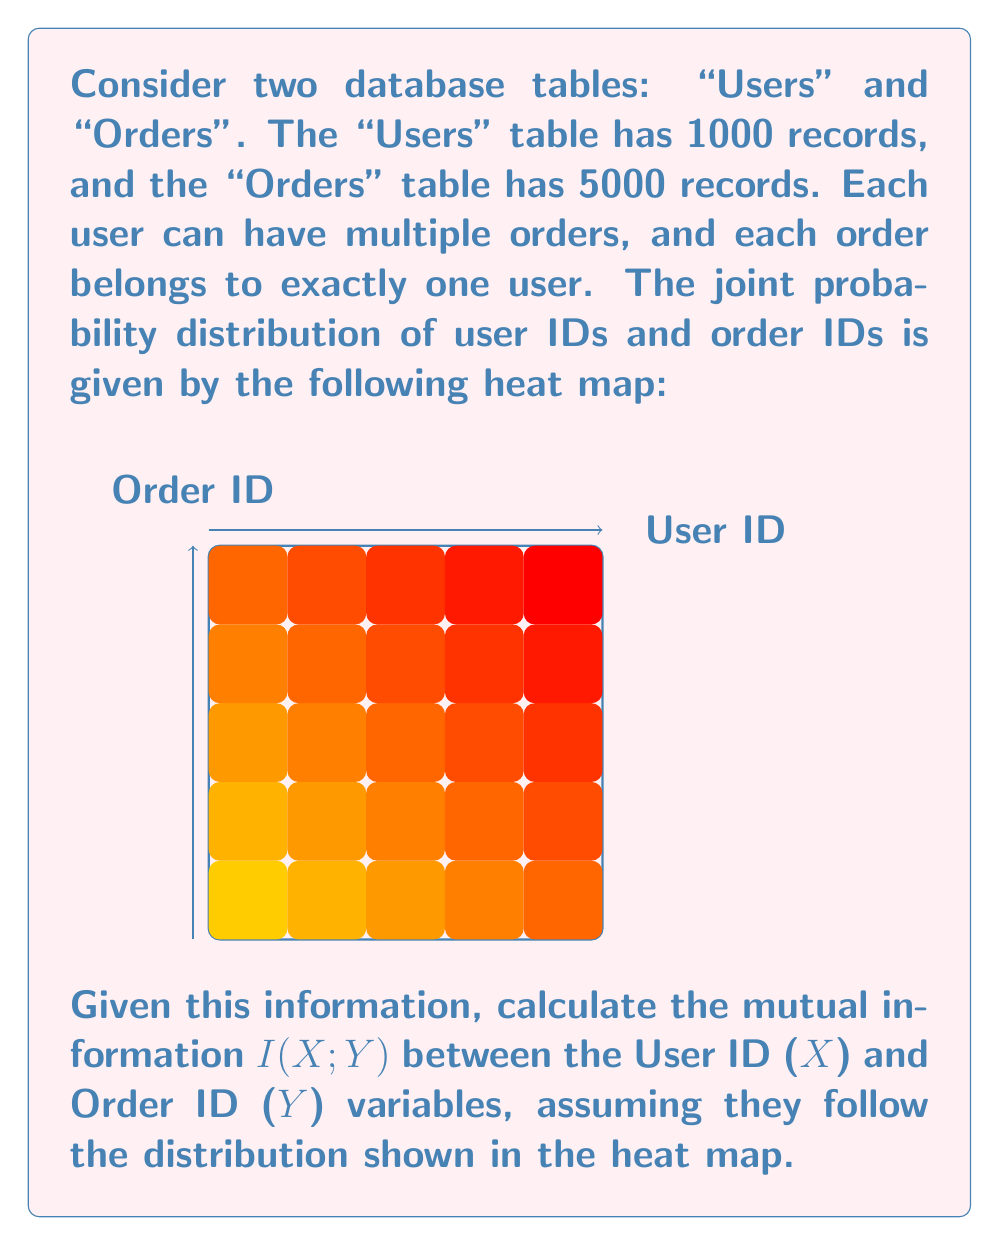Can you solve this math problem? To calculate the mutual information between User ID (X) and Order ID (Y), we'll follow these steps:

1) Mutual information is defined as:

   $$I(X;Y) = \sum_{x,y} p(x,y) \log_2 \frac{p(x,y)}{p(x)p(y)}$$

2) From the heat map, we can approximate the joint probability distribution $p(x,y)$. Let's assume the highest probability in the center is 0.04 and the lowest in the corners is 0.001.

3) To calculate $p(x)$ and $p(y)$, we need to sum $p(x,y)$ over y and x respectively:

   $$p(x) = \sum_y p(x,y)$$
   $$p(y) = \sum_x p(x,y)$$

4) Due to the symmetry of the heat map, we can assume $p(x)$ and $p(y)$ are uniform distributions:

   $$p(x) = p(y) = \frac{1}{10} = 0.1$$

5) Now, we can calculate the mutual information:

   $$I(X;Y) = \sum_{x,y} p(x,y) \log_2 \frac{p(x,y)}{0.1 * 0.1}$$

6) We need to sum this for all 100 combinations of x and y. Let's approximate this sum:

   - For the center point: $0.04 * \log_2 \frac{0.04}{0.01} = 0.08$ bits
   - For the corner points: $4 * 0.001 * \log_2 \frac{0.001}{0.01} = -0.0133$ bits
   - For the remaining points: $95 * 0.02 * \log_2 \frac{0.02}{0.01} = 1.3665$ bits

7) Summing these up:

   $$I(X;Y) \approx 0.08 - 0.0133 + 1.3665 = 1.4332 \text{ bits}$$

This result indicates a moderate level of mutual information between User IDs and Order IDs, suggesting some correlation between these variables in the database.
Answer: $1.4332 \text{ bits}$ 